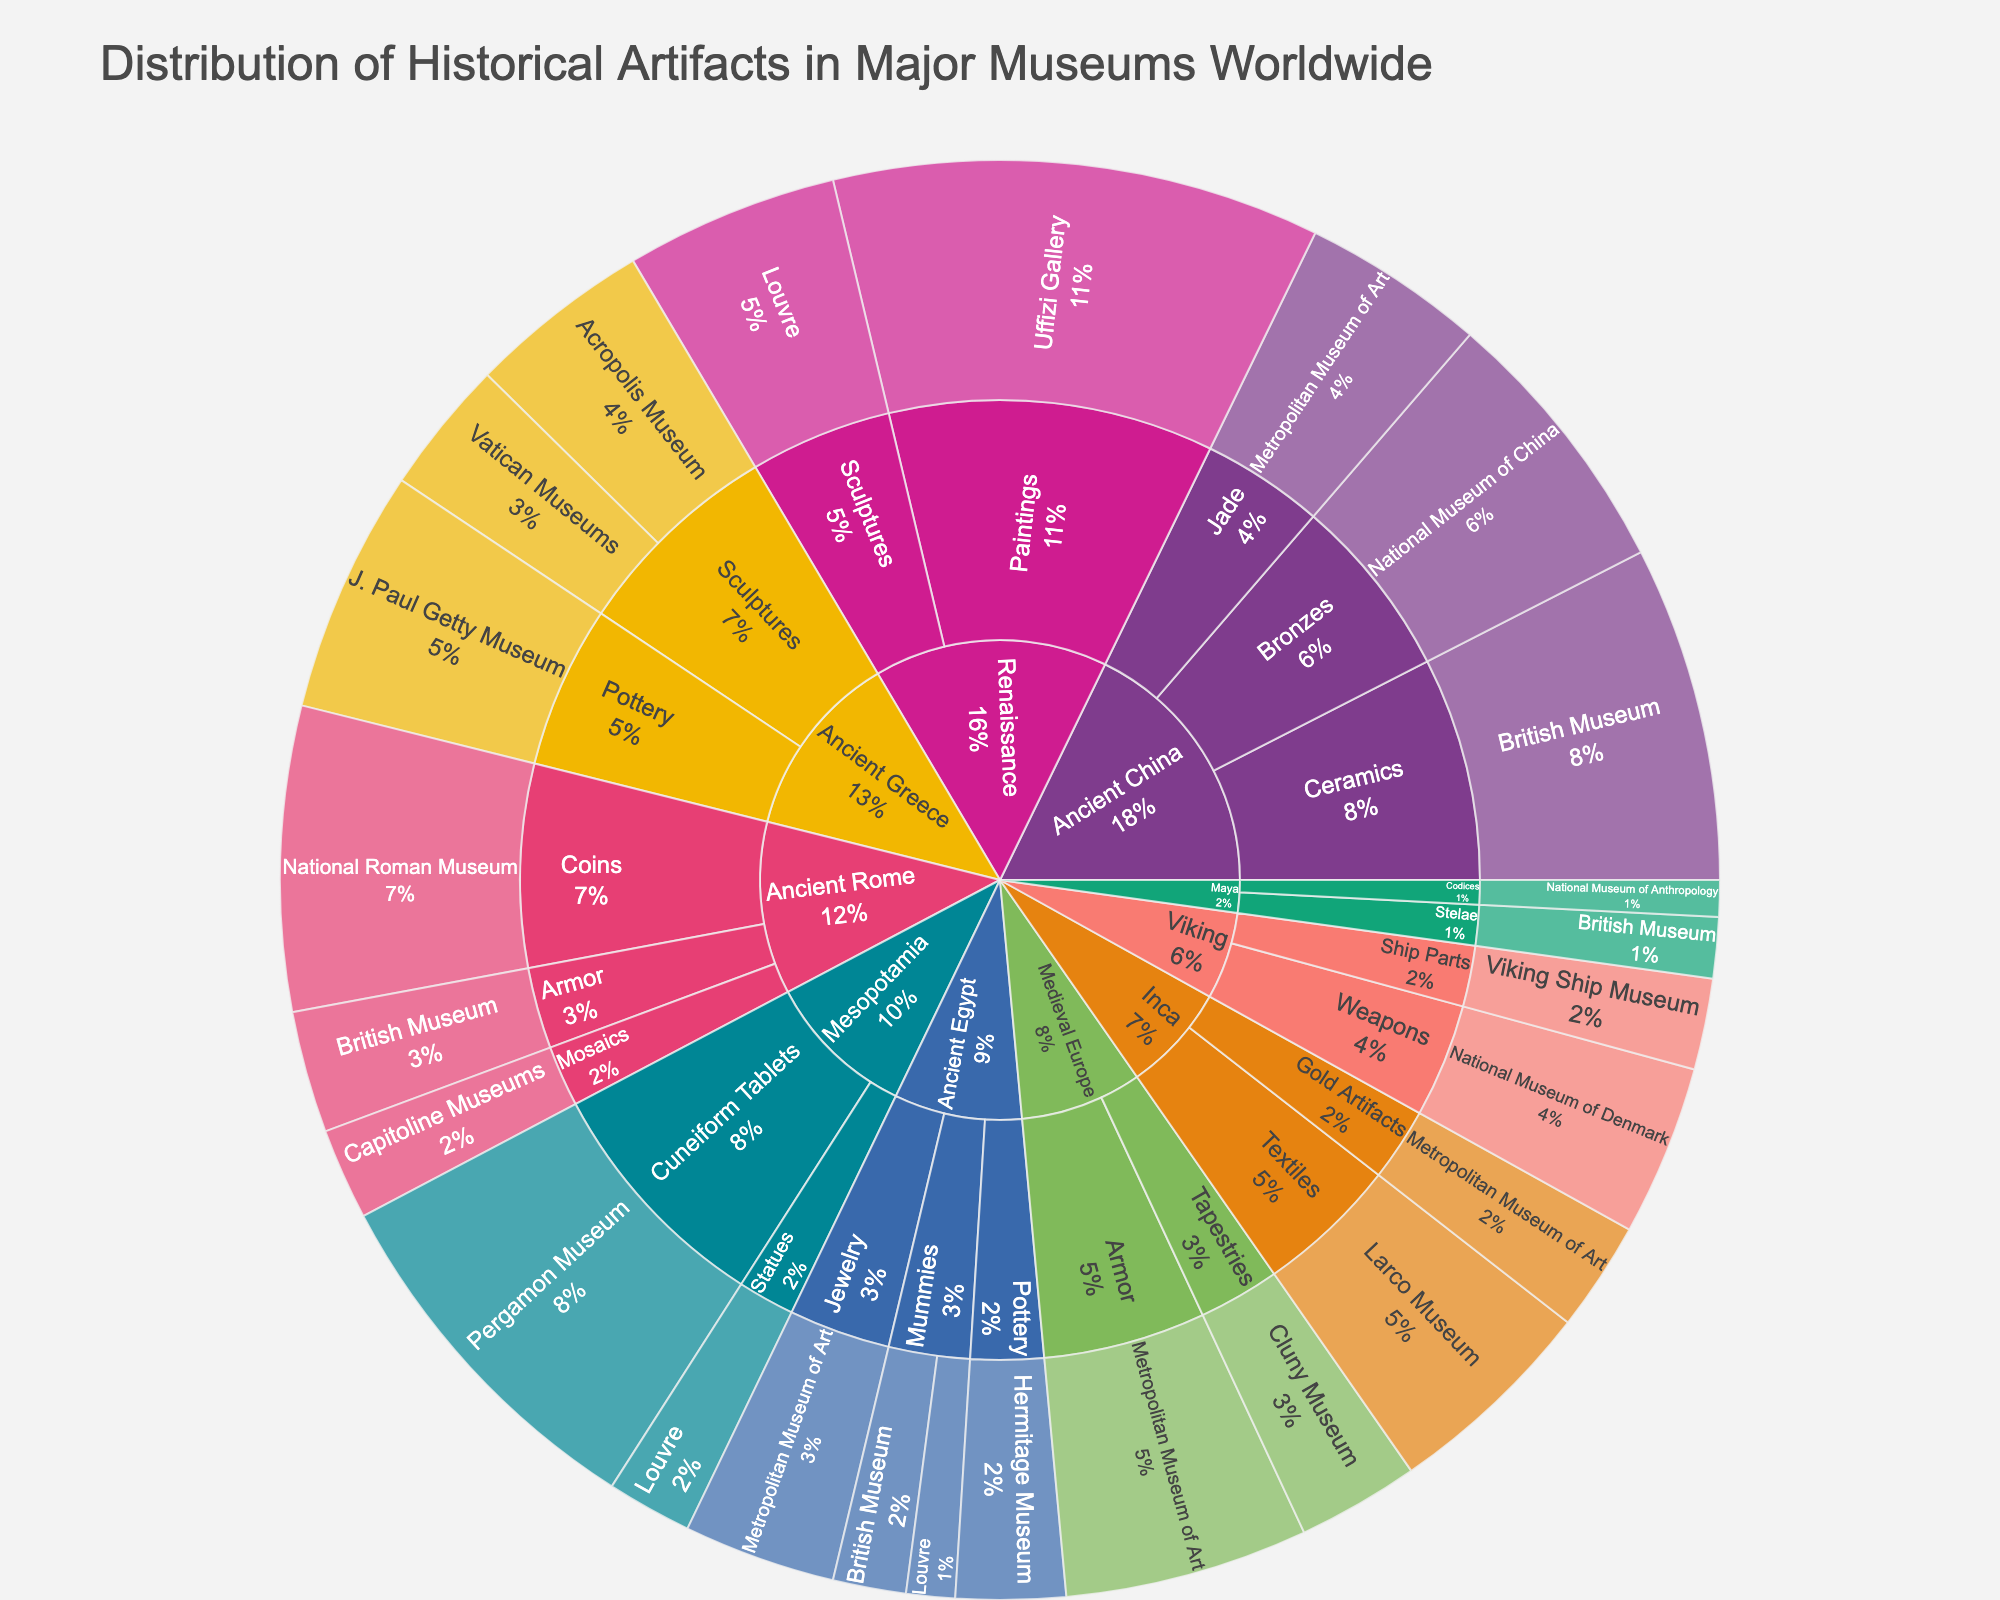What is the title of the plot? The title is usually displayed at the top of the Sunburst Plot. This information is extracted simply by locating the text at the top of the plot.
Answer: Distribution of Historical Artifacts in Major Museums Worldwide Which museum has the highest count of Ancient Egypt Jewelry artifacts? To answer this, locate the 'Ancient Egypt' section, followed by 'Jewelry', and then identify the museum with the highest count value within that category.
Answer: Metropolitan Museum of Art How many artifacts of the Viking civilization are displayed in the National Museum of Denmark? Identify the 'Viking' civilization segment, then find the segment for 'Weapons' which leads to 'National Museum of Denmark', and observe the count associated with it.
Answer: 28 Which civilization has the most artifacts overall? Observe each top-level segment for each civilization and sum up the counts of their respective artifacts to determine which has the highest total sum.
Answer: Ancient China What is the total number of artifacts from the British Museum? Identify all segments ending with 'British Museum' across all civilizations and artifact types, then calculate the sum of all these counts.
Answer: 97 Compare the counts of Viking Weapons and Ship Parts in their respective museums. Which has more? Locate the 'Viking' civilization’s segments for 'Weapons' (National Museum of Denmark) and 'Ship Parts' (Viking Ship Museum), then compare the counts.
Answer: Weapons How many types of artifacts does the Renaissance civilization have in the plot? Identify the 'Renaissance' segment and count the distinct artifact types listed under this civilization.
Answer: 2 What percentage of the total Ancient Greek Sculptures are located in the Acropolis Museum? Determine the total count of 'Sculptures' under 'Ancient Greece', sum the values, and find the percentage that is located in the Acropolis Museum. The ratio of the Acropolis Museum count to the total 'Sculptures' under 'Ancient Greece' is calculated.
Answer: 57.7% Which museum has the fewest Maya Codices artifacts? Identify the 'Maya' civilization and then 'Codices'. Compare the counts under the respective museums to determine which has the smallest number.
Answer: National Museum of Anthropology How does the number of Medieval European Armor artifacts in the Metropolitan Museum of Art compare to the number of Ancient Roman Armor artifacts in the British Museum? Locate 'Medieval Europe' -> 'Armor' -> 'Metropolitan Museum of Art' and 'Ancient Rome' -> 'Armor' -> 'British Museum', and compare their counts.
Answer: Metropolitan Museum of Art has more 